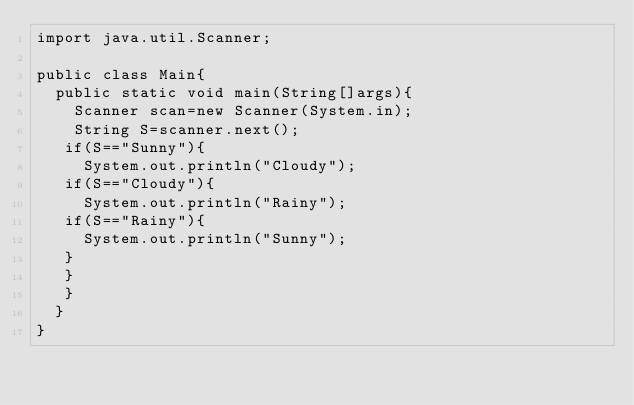<code> <loc_0><loc_0><loc_500><loc_500><_Java_>import java.util.Scanner;

public class Main{
  public static void main(String[]args){
    Scanner scan=new Scanner(System.in);
    String S=scanner.next();
   if(S=="Sunny"){
     System.out.println("Cloudy");
   if(S=="Cloudy"){
     System.out.println("Rainy");
   if(S=="Rainy"){
     System.out.println("Sunny");
   }
   }
   }
  }
}</code> 